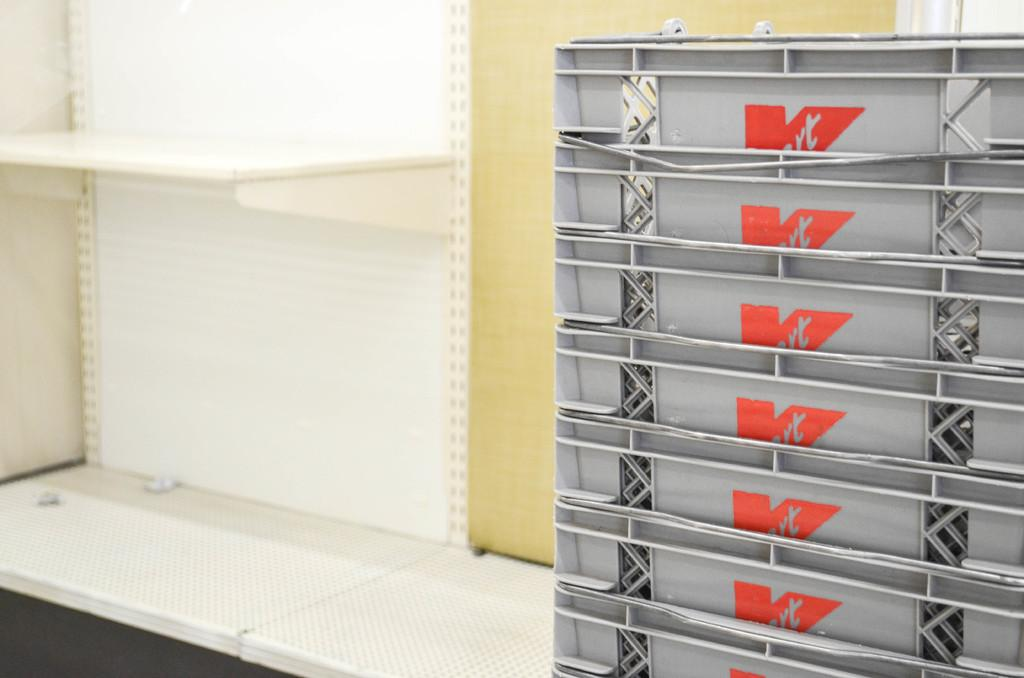<image>
Give a short and clear explanation of the subsequent image. A stack of K-Mart baskets sit in the back room of a store. 